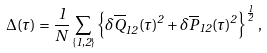<formula> <loc_0><loc_0><loc_500><loc_500>\Delta ( \tau ) = \frac { 1 } { N } \sum _ { \{ 1 , 2 \} } \left \{ \delta \overline { Q } _ { 1 2 } ( \tau ) ^ { 2 } + \delta \overline { P } _ { 1 2 } ( \tau ) ^ { 2 } \right \} ^ { \frac { 1 } { 2 } } ,</formula> 